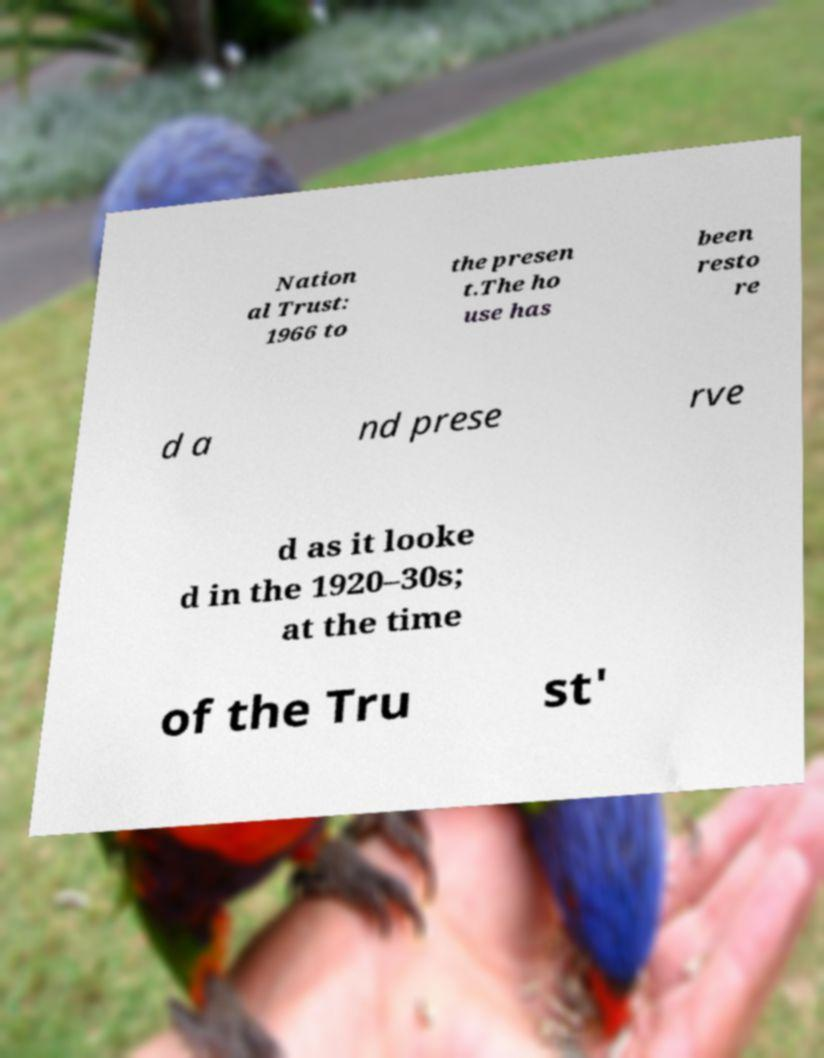Can you accurately transcribe the text from the provided image for me? Nation al Trust: 1966 to the presen t.The ho use has been resto re d a nd prese rve d as it looke d in the 1920–30s; at the time of the Tru st' 